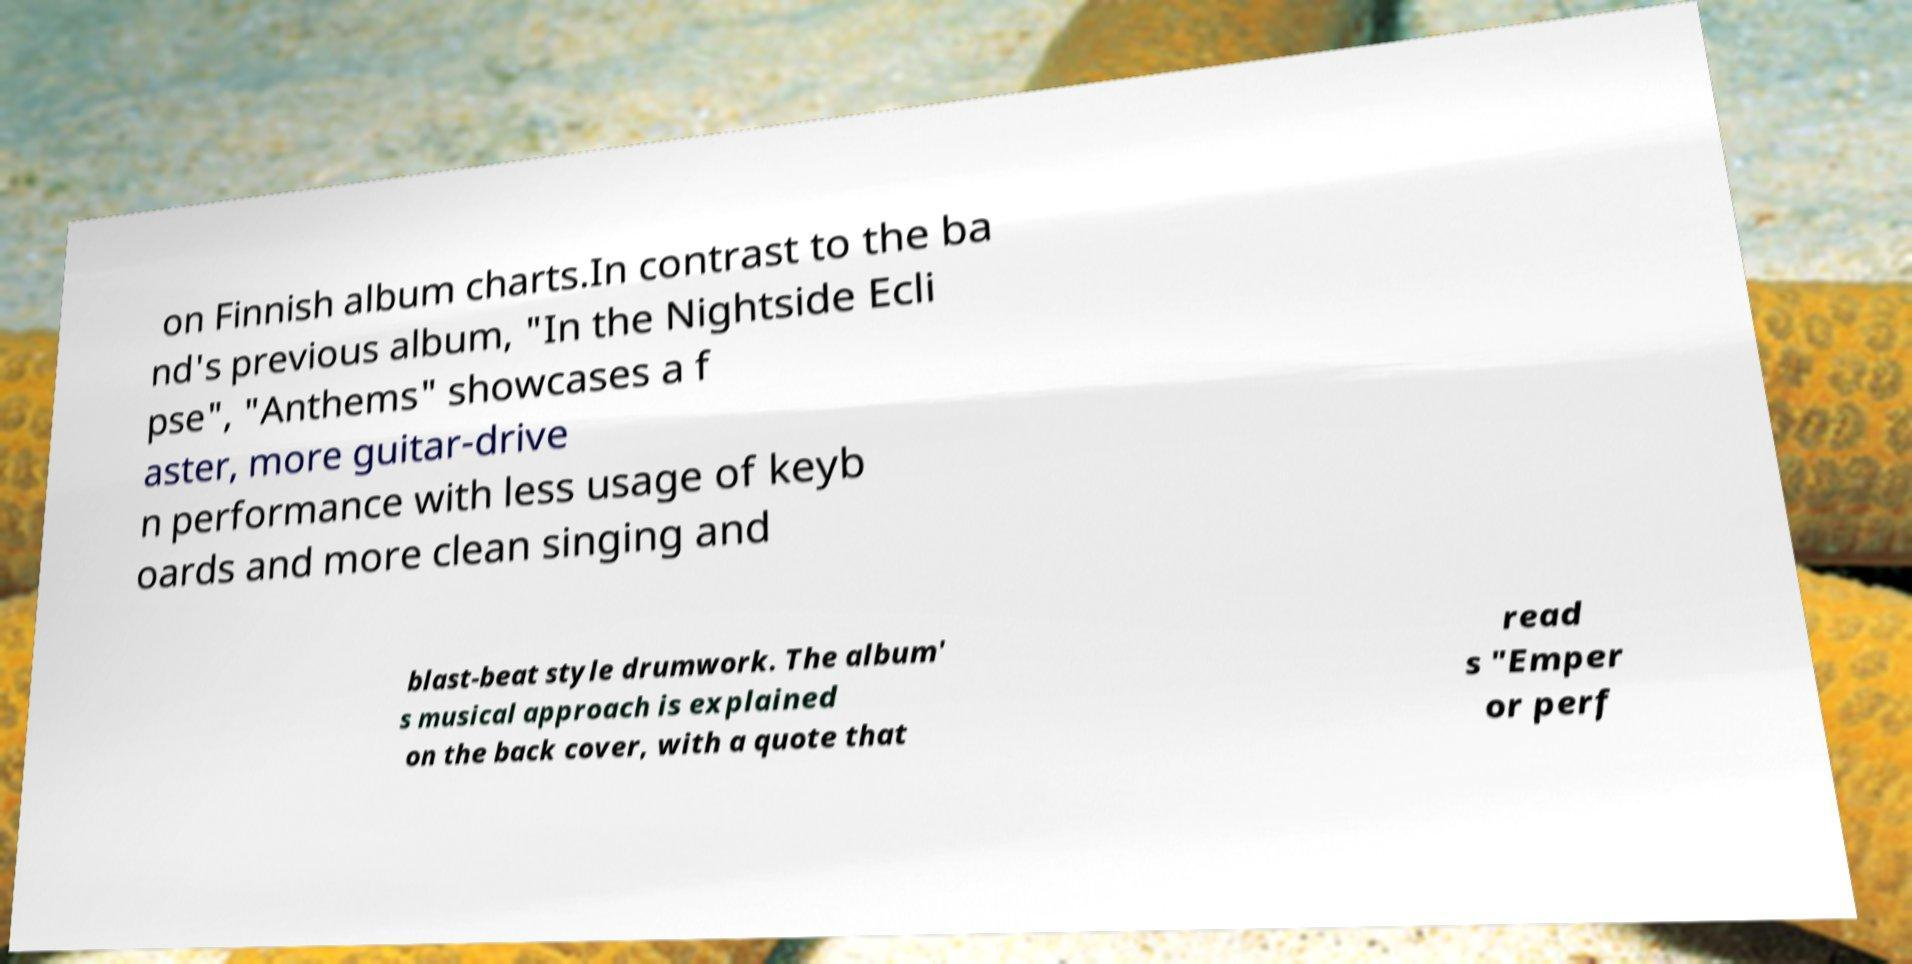Can you accurately transcribe the text from the provided image for me? on Finnish album charts.In contrast to the ba nd's previous album, "In the Nightside Ecli pse", "Anthems" showcases a f aster, more guitar-drive n performance with less usage of keyb oards and more clean singing and blast-beat style drumwork. The album' s musical approach is explained on the back cover, with a quote that read s "Emper or perf 